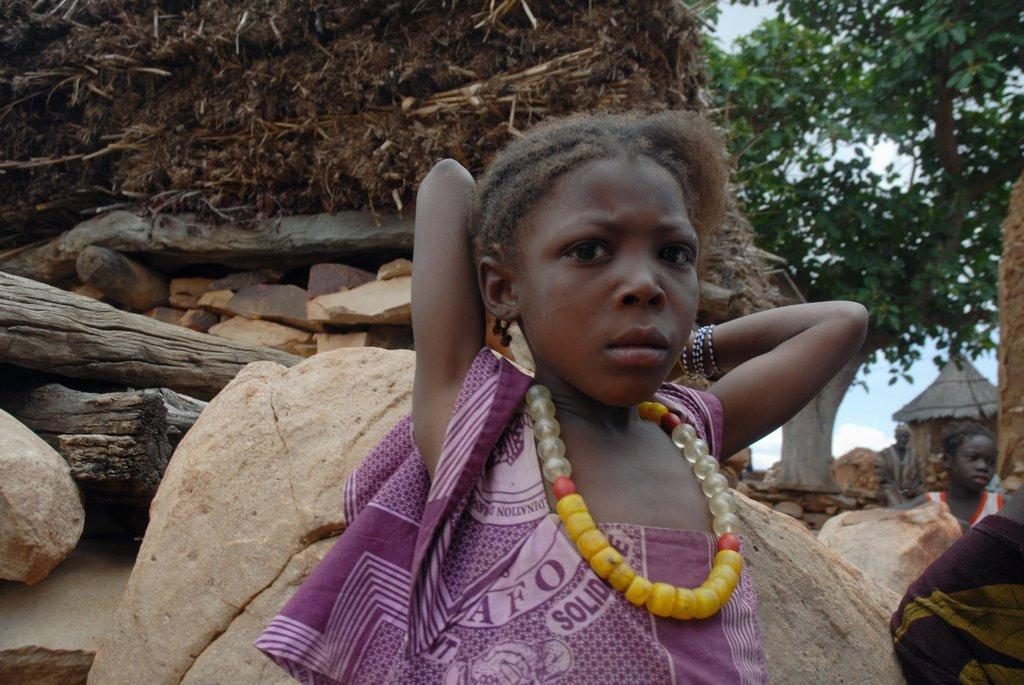Who is present in the image? There is a girl and a child in the image. What is the relationship between the girl and the child? The relationship between the girl and the child is not specified in the image. What type of objects can be seen in the image? There are rocks, wooden objects, and a hut in the image. What is the natural environment like in the image? The natural environment includes grass and a tree. What type of stem can be seen supporting the frame in the image? There is no stem or frame present in the image. What adjustment needs to be made to the hut in the image? There is no indication in the image that any adjustment needs to be made to the hut. 